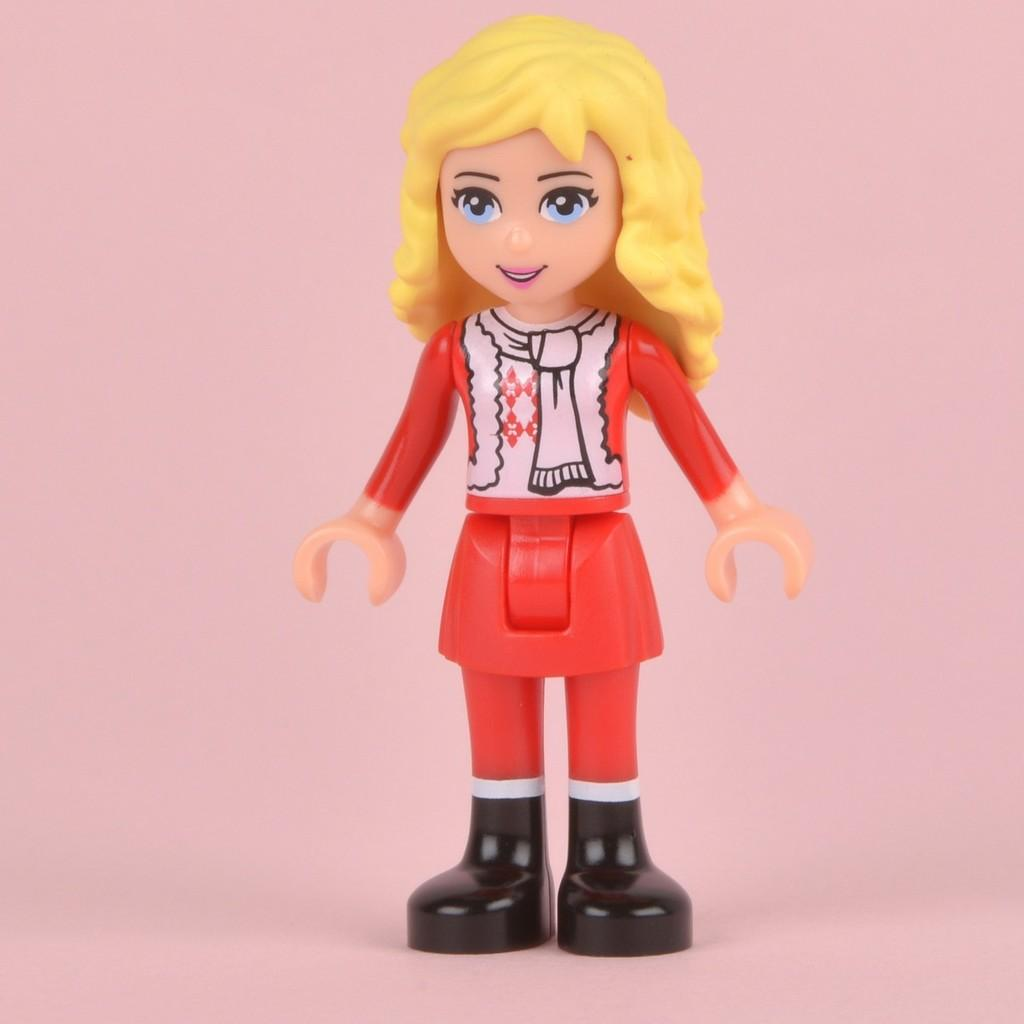What type of doll is in the image? There is a girl doll in the image. What colors can be seen on the doll? The colors of the doll include red, white, yellow, and black. What color is present in the background of the image? There is pink color visible in the background of the image. Can you tell me how the wax is being used by the doll in the image? There is no wax present in the image, and therefore no such interaction can be observed. 